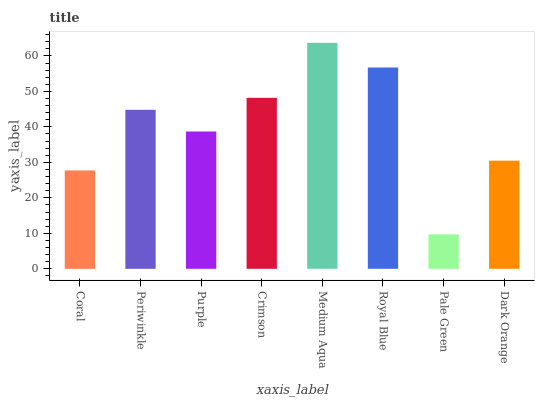Is Periwinkle the minimum?
Answer yes or no. No. Is Periwinkle the maximum?
Answer yes or no. No. Is Periwinkle greater than Coral?
Answer yes or no. Yes. Is Coral less than Periwinkle?
Answer yes or no. Yes. Is Coral greater than Periwinkle?
Answer yes or no. No. Is Periwinkle less than Coral?
Answer yes or no. No. Is Periwinkle the high median?
Answer yes or no. Yes. Is Purple the low median?
Answer yes or no. Yes. Is Dark Orange the high median?
Answer yes or no. No. Is Dark Orange the low median?
Answer yes or no. No. 